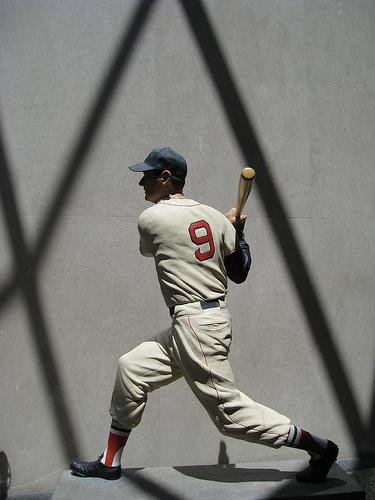Examine the image and describe the shadow present in the scene. There is a shadow of the player's leg and a shadow of a fence in the background on the ground. Identify the scene taking place in the image. A baseball player in a white uniform and blue hat is standing and holding a light brown wooden bat. Assess the emotional undertone of the image. The image has a competitive and focused sports sentiment. What number is displayed on the baseball player's shirt and what color is it? The number 9 is on the player's shirt and it is red. Briefly narrate the appearance of the baseball player's pants. The baseball player is wearing white pants with a red line down the side and a gray belt with white buckles. What type of shoes is the baseball player wearing and what color are they? The player is wearing a pair of black baseball cleats. What color is the hat worn by the baseball player? The baseball player is wearing a black cap. Analyze the interaction between the baseball player's leg and the ground. The player's left leg is positioned back, and the left heel is lifted slightly off the ground. List the colors present on the socks of the baseball player. The player's socks are red, blue, and white. In the image, how many baseball-related objects can you identify? There are 4 baseball-related objects: player, bat, cap, and baseball cleats. Identify the primary colors found on the baseball player's socks. Red and white Which of these best describes the baseball player's position: a) standing with left leg back b) crouching down c) sitting on a bench a) standing with left leg back Can you see the orange stripe on the man's pants? The stripe on the man's pants is actually red (X:178 Y:304 Width:90 Height:90) and there is no mention of an orange stripe in the image. Identify the color and design on the baseball player's socks. Red, blue, and white stripes Mention the position of the baseball player regarding the baseball bat he is holding. holding bat with both hands, possibly getting ready to hit the ball Mention the color of the number 9 on the baseball player's shirt. Red What is the color of the baseball player's shoes? Black Are the socks blue and green? The socks are actually red, blue, and white (X:91 Y:417 Width:216 Height:216) and red and white (X:86 Y:405 Width:57 Height:57), but there is no mention of blue and green socks in the image. Describe the jersey of the baseball player in the image. White with black sleeves and a red number nine on the back Is the number 7 visible on the man's shirt? The number on the man's shirt is actually 9 (X:185 Y:212 Width:33 Height:33), not 7. Which hand is the baseball player using to hold the bat? Unable to determine Select the accurate description of the baseball player's belt: a) black belt with a gold buckle b) gray belt with white buckles c) blue belt with a silver buckle b) gray belt with white buckles Is there a shadow visible in the image? If so, describe its location and possible cause. Yes, shadow of the fence in the background and shadow of player's leg on the ground. Is the baseball player wearing a green hat? The baseball player is actually wearing a blue hat (X:125 Y:149 Width:77 Height:77) and a black cap (X:130 Y:144 Width:57 Height:57), but there is no mention of a green hat in the image. Does the baseball player have a large right ear? The image only mentions a small left ear (X:158 Y:167 Width:12 Height:12) and does not mention the size or presence of the player's right ear. Is the baseball player wearing a hat or a helmet? What color is it? Wearing a hat, black color Describe the kinds of details found on the baseball player's pants. Red stripe going down side, back pocket, gray belt with white buckles Describe the appearance of the baseball bat in the image. Light brown wooden baseball bat What activity can be recognized in the image? Baseball player getting ready to hit the ball Is the baseball bat made of metal? The baseball bat is described as light brown wooden (X:234 Y:166 Width:19 Height:19), so it is not made of metal. Find the connection between a baseball player and a small baseball player figurine. They both represent baseball and share similar features, Analyse the footwear of the baseball player and mention its color and distinguishing feature. Black shoes, with black baseball cleat What color is the baseball player's uniform, and what number is on the back? White, 9 